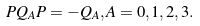<formula> <loc_0><loc_0><loc_500><loc_500>P Q _ { A } P = - Q _ { A } , A = 0 , 1 , 2 , 3 .</formula> 